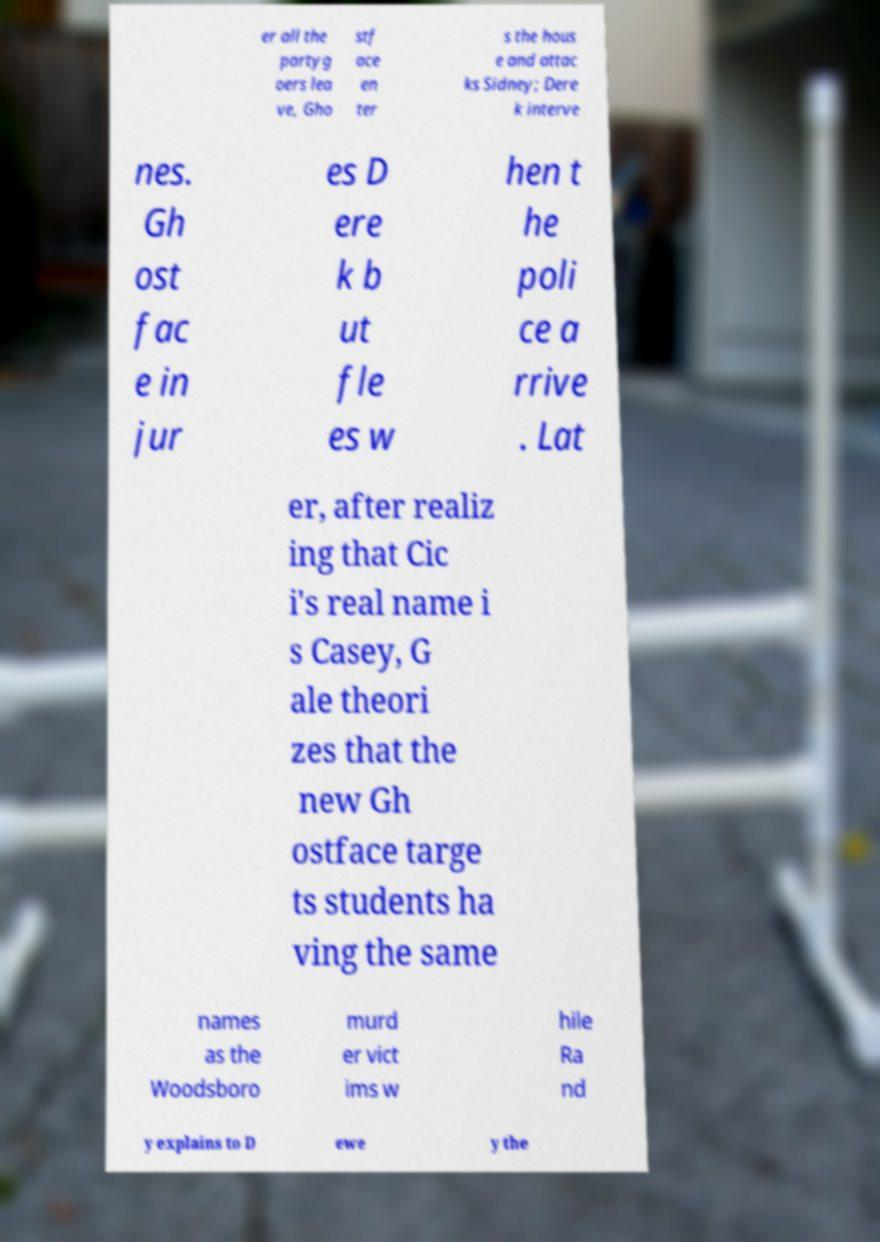Could you assist in decoding the text presented in this image and type it out clearly? er all the partyg oers lea ve, Gho stf ace en ter s the hous e and attac ks Sidney; Dere k interve nes. Gh ost fac e in jur es D ere k b ut fle es w hen t he poli ce a rrive . Lat er, after realiz ing that Cic i's real name i s Casey, G ale theori zes that the new Gh ostface targe ts students ha ving the same names as the Woodsboro murd er vict ims w hile Ra nd y explains to D ewe y the 